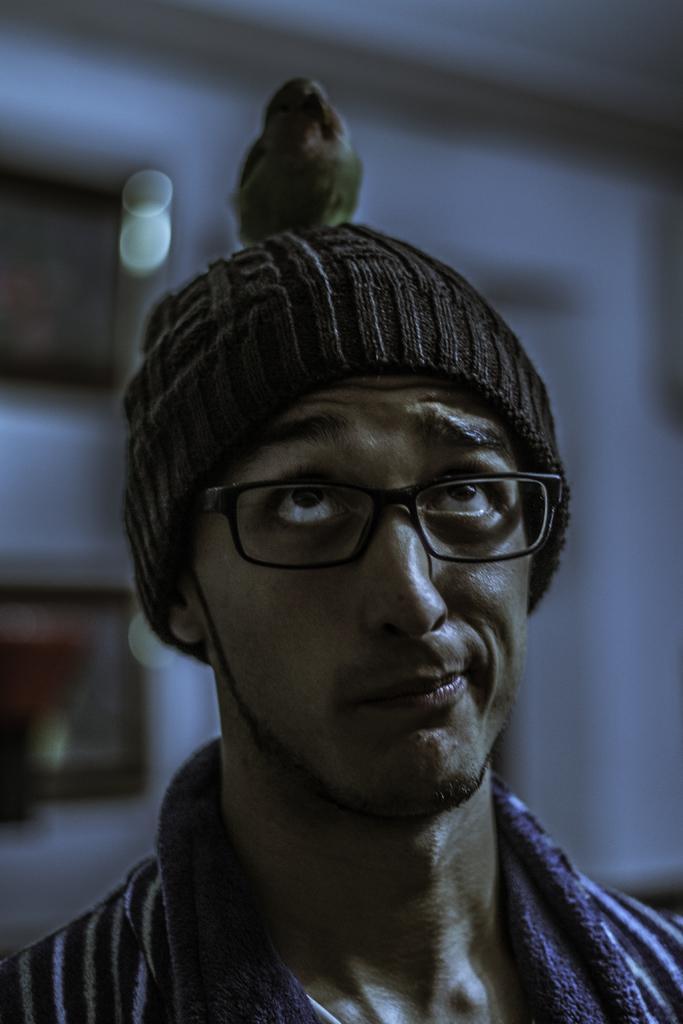Please provide a concise description of this image. In this picture I can see a man, he is wearing a cap. There is a bird on his head. 